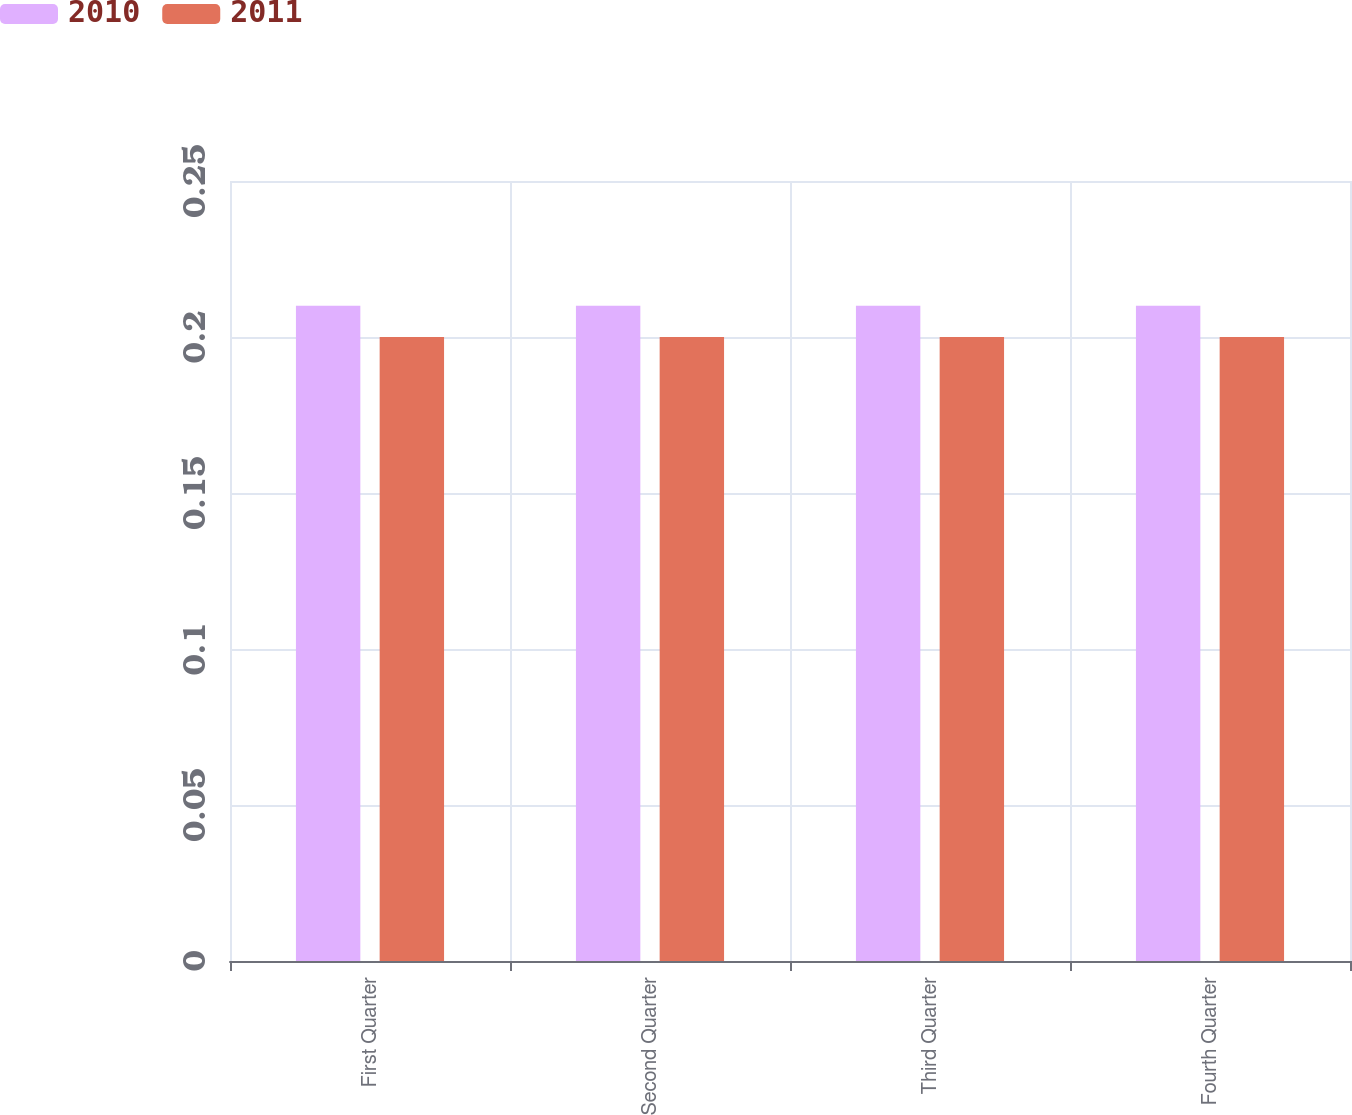Convert chart to OTSL. <chart><loc_0><loc_0><loc_500><loc_500><stacked_bar_chart><ecel><fcel>First Quarter<fcel>Second Quarter<fcel>Third Quarter<fcel>Fourth Quarter<nl><fcel>2010<fcel>0.21<fcel>0.21<fcel>0.21<fcel>0.21<nl><fcel>2011<fcel>0.2<fcel>0.2<fcel>0.2<fcel>0.2<nl></chart> 